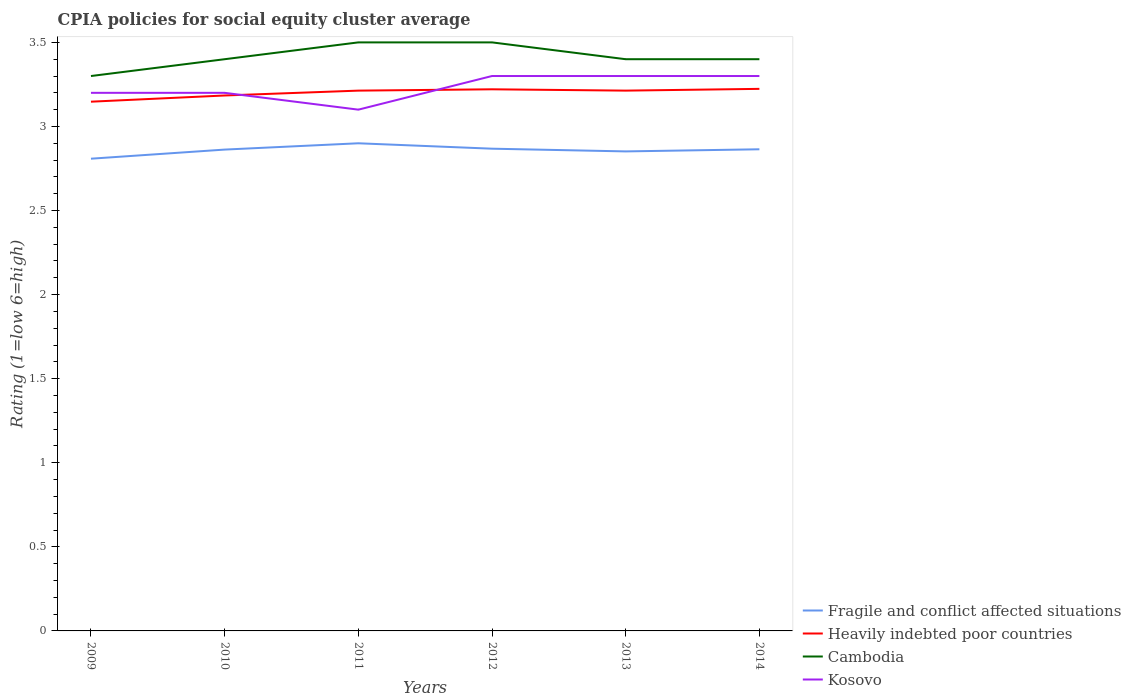Does the line corresponding to Cambodia intersect with the line corresponding to Heavily indebted poor countries?
Offer a terse response. No. Is the number of lines equal to the number of legend labels?
Your response must be concise. Yes. Across all years, what is the maximum CPIA rating in Fragile and conflict affected situations?
Your response must be concise. 2.81. In which year was the CPIA rating in Cambodia maximum?
Your answer should be very brief. 2009. What is the total CPIA rating in Heavily indebted poor countries in the graph?
Offer a very short reply. -0.03. What is the difference between the highest and the second highest CPIA rating in Kosovo?
Ensure brevity in your answer.  0.2. What is the difference between the highest and the lowest CPIA rating in Kosovo?
Offer a terse response. 3. How many lines are there?
Your answer should be compact. 4. How many years are there in the graph?
Give a very brief answer. 6. Are the values on the major ticks of Y-axis written in scientific E-notation?
Your answer should be very brief. No. Does the graph contain any zero values?
Make the answer very short. No. Where does the legend appear in the graph?
Your answer should be compact. Bottom right. What is the title of the graph?
Your response must be concise. CPIA policies for social equity cluster average. Does "Least developed countries" appear as one of the legend labels in the graph?
Make the answer very short. No. What is the label or title of the Y-axis?
Give a very brief answer. Rating (1=low 6=high). What is the Rating (1=low 6=high) in Fragile and conflict affected situations in 2009?
Your response must be concise. 2.81. What is the Rating (1=low 6=high) in Heavily indebted poor countries in 2009?
Your response must be concise. 3.15. What is the Rating (1=low 6=high) of Fragile and conflict affected situations in 2010?
Provide a short and direct response. 2.86. What is the Rating (1=low 6=high) in Heavily indebted poor countries in 2010?
Provide a succinct answer. 3.18. What is the Rating (1=low 6=high) of Fragile and conflict affected situations in 2011?
Your answer should be compact. 2.9. What is the Rating (1=low 6=high) of Heavily indebted poor countries in 2011?
Your answer should be very brief. 3.21. What is the Rating (1=low 6=high) in Kosovo in 2011?
Provide a short and direct response. 3.1. What is the Rating (1=low 6=high) in Fragile and conflict affected situations in 2012?
Provide a short and direct response. 2.87. What is the Rating (1=low 6=high) in Heavily indebted poor countries in 2012?
Your response must be concise. 3.22. What is the Rating (1=low 6=high) in Cambodia in 2012?
Provide a succinct answer. 3.5. What is the Rating (1=low 6=high) in Kosovo in 2012?
Make the answer very short. 3.3. What is the Rating (1=low 6=high) of Fragile and conflict affected situations in 2013?
Give a very brief answer. 2.85. What is the Rating (1=low 6=high) in Heavily indebted poor countries in 2013?
Your answer should be very brief. 3.21. What is the Rating (1=low 6=high) in Cambodia in 2013?
Offer a very short reply. 3.4. What is the Rating (1=low 6=high) of Kosovo in 2013?
Your answer should be compact. 3.3. What is the Rating (1=low 6=high) in Fragile and conflict affected situations in 2014?
Ensure brevity in your answer.  2.86. What is the Rating (1=low 6=high) in Heavily indebted poor countries in 2014?
Your answer should be very brief. 3.22. Across all years, what is the maximum Rating (1=low 6=high) in Heavily indebted poor countries?
Offer a very short reply. 3.22. Across all years, what is the maximum Rating (1=low 6=high) of Cambodia?
Your answer should be compact. 3.5. Across all years, what is the maximum Rating (1=low 6=high) of Kosovo?
Provide a short and direct response. 3.3. Across all years, what is the minimum Rating (1=low 6=high) in Fragile and conflict affected situations?
Provide a short and direct response. 2.81. Across all years, what is the minimum Rating (1=low 6=high) in Heavily indebted poor countries?
Give a very brief answer. 3.15. Across all years, what is the minimum Rating (1=low 6=high) of Kosovo?
Keep it short and to the point. 3.1. What is the total Rating (1=low 6=high) of Fragile and conflict affected situations in the graph?
Ensure brevity in your answer.  17.15. What is the total Rating (1=low 6=high) of Heavily indebted poor countries in the graph?
Ensure brevity in your answer.  19.2. What is the total Rating (1=low 6=high) of Cambodia in the graph?
Your response must be concise. 20.5. What is the total Rating (1=low 6=high) in Kosovo in the graph?
Your answer should be compact. 19.4. What is the difference between the Rating (1=low 6=high) of Fragile and conflict affected situations in 2009 and that in 2010?
Provide a short and direct response. -0.05. What is the difference between the Rating (1=low 6=high) in Heavily indebted poor countries in 2009 and that in 2010?
Offer a terse response. -0.04. What is the difference between the Rating (1=low 6=high) of Cambodia in 2009 and that in 2010?
Keep it short and to the point. -0.1. What is the difference between the Rating (1=low 6=high) in Fragile and conflict affected situations in 2009 and that in 2011?
Provide a short and direct response. -0.09. What is the difference between the Rating (1=low 6=high) of Heavily indebted poor countries in 2009 and that in 2011?
Give a very brief answer. -0.07. What is the difference between the Rating (1=low 6=high) in Cambodia in 2009 and that in 2011?
Make the answer very short. -0.2. What is the difference between the Rating (1=low 6=high) in Kosovo in 2009 and that in 2011?
Make the answer very short. 0.1. What is the difference between the Rating (1=low 6=high) of Fragile and conflict affected situations in 2009 and that in 2012?
Keep it short and to the point. -0.06. What is the difference between the Rating (1=low 6=high) of Heavily indebted poor countries in 2009 and that in 2012?
Keep it short and to the point. -0.07. What is the difference between the Rating (1=low 6=high) in Kosovo in 2009 and that in 2012?
Your response must be concise. -0.1. What is the difference between the Rating (1=low 6=high) of Fragile and conflict affected situations in 2009 and that in 2013?
Keep it short and to the point. -0.04. What is the difference between the Rating (1=low 6=high) in Heavily indebted poor countries in 2009 and that in 2013?
Your answer should be very brief. -0.07. What is the difference between the Rating (1=low 6=high) in Cambodia in 2009 and that in 2013?
Offer a terse response. -0.1. What is the difference between the Rating (1=low 6=high) of Kosovo in 2009 and that in 2013?
Provide a succinct answer. -0.1. What is the difference between the Rating (1=low 6=high) in Fragile and conflict affected situations in 2009 and that in 2014?
Offer a very short reply. -0.06. What is the difference between the Rating (1=low 6=high) in Heavily indebted poor countries in 2009 and that in 2014?
Your answer should be very brief. -0.08. What is the difference between the Rating (1=low 6=high) in Cambodia in 2009 and that in 2014?
Your answer should be compact. -0.1. What is the difference between the Rating (1=low 6=high) of Fragile and conflict affected situations in 2010 and that in 2011?
Your response must be concise. -0.04. What is the difference between the Rating (1=low 6=high) in Heavily indebted poor countries in 2010 and that in 2011?
Your response must be concise. -0.03. What is the difference between the Rating (1=low 6=high) in Cambodia in 2010 and that in 2011?
Provide a short and direct response. -0.1. What is the difference between the Rating (1=low 6=high) in Fragile and conflict affected situations in 2010 and that in 2012?
Give a very brief answer. -0.01. What is the difference between the Rating (1=low 6=high) in Heavily indebted poor countries in 2010 and that in 2012?
Your answer should be compact. -0.04. What is the difference between the Rating (1=low 6=high) of Kosovo in 2010 and that in 2012?
Your answer should be very brief. -0.1. What is the difference between the Rating (1=low 6=high) in Fragile and conflict affected situations in 2010 and that in 2013?
Offer a very short reply. 0.01. What is the difference between the Rating (1=low 6=high) of Heavily indebted poor countries in 2010 and that in 2013?
Offer a terse response. -0.03. What is the difference between the Rating (1=low 6=high) of Cambodia in 2010 and that in 2013?
Your response must be concise. 0. What is the difference between the Rating (1=low 6=high) in Kosovo in 2010 and that in 2013?
Provide a short and direct response. -0.1. What is the difference between the Rating (1=low 6=high) in Fragile and conflict affected situations in 2010 and that in 2014?
Provide a short and direct response. -0. What is the difference between the Rating (1=low 6=high) in Heavily indebted poor countries in 2010 and that in 2014?
Your answer should be compact. -0.04. What is the difference between the Rating (1=low 6=high) in Cambodia in 2010 and that in 2014?
Make the answer very short. 0. What is the difference between the Rating (1=low 6=high) of Kosovo in 2010 and that in 2014?
Provide a succinct answer. -0.1. What is the difference between the Rating (1=low 6=high) in Fragile and conflict affected situations in 2011 and that in 2012?
Your answer should be compact. 0.03. What is the difference between the Rating (1=low 6=high) of Heavily indebted poor countries in 2011 and that in 2012?
Ensure brevity in your answer.  -0.01. What is the difference between the Rating (1=low 6=high) in Cambodia in 2011 and that in 2012?
Make the answer very short. 0. What is the difference between the Rating (1=low 6=high) of Kosovo in 2011 and that in 2012?
Give a very brief answer. -0.2. What is the difference between the Rating (1=low 6=high) in Fragile and conflict affected situations in 2011 and that in 2013?
Give a very brief answer. 0.05. What is the difference between the Rating (1=low 6=high) in Kosovo in 2011 and that in 2013?
Give a very brief answer. -0.2. What is the difference between the Rating (1=low 6=high) of Fragile and conflict affected situations in 2011 and that in 2014?
Keep it short and to the point. 0.04. What is the difference between the Rating (1=low 6=high) in Heavily indebted poor countries in 2011 and that in 2014?
Ensure brevity in your answer.  -0.01. What is the difference between the Rating (1=low 6=high) in Cambodia in 2011 and that in 2014?
Provide a short and direct response. 0.1. What is the difference between the Rating (1=low 6=high) of Kosovo in 2011 and that in 2014?
Give a very brief answer. -0.2. What is the difference between the Rating (1=low 6=high) in Fragile and conflict affected situations in 2012 and that in 2013?
Offer a very short reply. 0.02. What is the difference between the Rating (1=low 6=high) in Heavily indebted poor countries in 2012 and that in 2013?
Offer a very short reply. 0.01. What is the difference between the Rating (1=low 6=high) of Cambodia in 2012 and that in 2013?
Offer a very short reply. 0.1. What is the difference between the Rating (1=low 6=high) of Kosovo in 2012 and that in 2013?
Offer a very short reply. 0. What is the difference between the Rating (1=low 6=high) in Fragile and conflict affected situations in 2012 and that in 2014?
Your answer should be very brief. 0. What is the difference between the Rating (1=low 6=high) in Heavily indebted poor countries in 2012 and that in 2014?
Ensure brevity in your answer.  -0. What is the difference between the Rating (1=low 6=high) of Cambodia in 2012 and that in 2014?
Offer a terse response. 0.1. What is the difference between the Rating (1=low 6=high) of Fragile and conflict affected situations in 2013 and that in 2014?
Offer a terse response. -0.01. What is the difference between the Rating (1=low 6=high) in Heavily indebted poor countries in 2013 and that in 2014?
Your answer should be compact. -0.01. What is the difference between the Rating (1=low 6=high) in Cambodia in 2013 and that in 2014?
Ensure brevity in your answer.  0. What is the difference between the Rating (1=low 6=high) in Fragile and conflict affected situations in 2009 and the Rating (1=low 6=high) in Heavily indebted poor countries in 2010?
Your response must be concise. -0.38. What is the difference between the Rating (1=low 6=high) in Fragile and conflict affected situations in 2009 and the Rating (1=low 6=high) in Cambodia in 2010?
Your response must be concise. -0.59. What is the difference between the Rating (1=low 6=high) of Fragile and conflict affected situations in 2009 and the Rating (1=low 6=high) of Kosovo in 2010?
Your answer should be compact. -0.39. What is the difference between the Rating (1=low 6=high) of Heavily indebted poor countries in 2009 and the Rating (1=low 6=high) of Cambodia in 2010?
Provide a succinct answer. -0.25. What is the difference between the Rating (1=low 6=high) of Heavily indebted poor countries in 2009 and the Rating (1=low 6=high) of Kosovo in 2010?
Provide a short and direct response. -0.05. What is the difference between the Rating (1=low 6=high) in Cambodia in 2009 and the Rating (1=low 6=high) in Kosovo in 2010?
Provide a short and direct response. 0.1. What is the difference between the Rating (1=low 6=high) in Fragile and conflict affected situations in 2009 and the Rating (1=low 6=high) in Heavily indebted poor countries in 2011?
Provide a short and direct response. -0.4. What is the difference between the Rating (1=low 6=high) of Fragile and conflict affected situations in 2009 and the Rating (1=low 6=high) of Cambodia in 2011?
Ensure brevity in your answer.  -0.69. What is the difference between the Rating (1=low 6=high) in Fragile and conflict affected situations in 2009 and the Rating (1=low 6=high) in Kosovo in 2011?
Make the answer very short. -0.29. What is the difference between the Rating (1=low 6=high) in Heavily indebted poor countries in 2009 and the Rating (1=low 6=high) in Cambodia in 2011?
Provide a short and direct response. -0.35. What is the difference between the Rating (1=low 6=high) of Heavily indebted poor countries in 2009 and the Rating (1=low 6=high) of Kosovo in 2011?
Your answer should be very brief. 0.05. What is the difference between the Rating (1=low 6=high) of Fragile and conflict affected situations in 2009 and the Rating (1=low 6=high) of Heavily indebted poor countries in 2012?
Provide a short and direct response. -0.41. What is the difference between the Rating (1=low 6=high) of Fragile and conflict affected situations in 2009 and the Rating (1=low 6=high) of Cambodia in 2012?
Offer a very short reply. -0.69. What is the difference between the Rating (1=low 6=high) of Fragile and conflict affected situations in 2009 and the Rating (1=low 6=high) of Kosovo in 2012?
Provide a short and direct response. -0.49. What is the difference between the Rating (1=low 6=high) of Heavily indebted poor countries in 2009 and the Rating (1=low 6=high) of Cambodia in 2012?
Keep it short and to the point. -0.35. What is the difference between the Rating (1=low 6=high) in Heavily indebted poor countries in 2009 and the Rating (1=low 6=high) in Kosovo in 2012?
Your answer should be compact. -0.15. What is the difference between the Rating (1=low 6=high) of Cambodia in 2009 and the Rating (1=low 6=high) of Kosovo in 2012?
Your response must be concise. 0. What is the difference between the Rating (1=low 6=high) in Fragile and conflict affected situations in 2009 and the Rating (1=low 6=high) in Heavily indebted poor countries in 2013?
Give a very brief answer. -0.4. What is the difference between the Rating (1=low 6=high) of Fragile and conflict affected situations in 2009 and the Rating (1=low 6=high) of Cambodia in 2013?
Your answer should be compact. -0.59. What is the difference between the Rating (1=low 6=high) in Fragile and conflict affected situations in 2009 and the Rating (1=low 6=high) in Kosovo in 2013?
Ensure brevity in your answer.  -0.49. What is the difference between the Rating (1=low 6=high) of Heavily indebted poor countries in 2009 and the Rating (1=low 6=high) of Cambodia in 2013?
Offer a terse response. -0.25. What is the difference between the Rating (1=low 6=high) of Heavily indebted poor countries in 2009 and the Rating (1=low 6=high) of Kosovo in 2013?
Provide a short and direct response. -0.15. What is the difference between the Rating (1=low 6=high) in Cambodia in 2009 and the Rating (1=low 6=high) in Kosovo in 2013?
Offer a very short reply. 0. What is the difference between the Rating (1=low 6=high) in Fragile and conflict affected situations in 2009 and the Rating (1=low 6=high) in Heavily indebted poor countries in 2014?
Your answer should be very brief. -0.42. What is the difference between the Rating (1=low 6=high) in Fragile and conflict affected situations in 2009 and the Rating (1=low 6=high) in Cambodia in 2014?
Give a very brief answer. -0.59. What is the difference between the Rating (1=low 6=high) of Fragile and conflict affected situations in 2009 and the Rating (1=low 6=high) of Kosovo in 2014?
Your answer should be compact. -0.49. What is the difference between the Rating (1=low 6=high) in Heavily indebted poor countries in 2009 and the Rating (1=low 6=high) in Cambodia in 2014?
Your answer should be compact. -0.25. What is the difference between the Rating (1=low 6=high) in Heavily indebted poor countries in 2009 and the Rating (1=low 6=high) in Kosovo in 2014?
Keep it short and to the point. -0.15. What is the difference between the Rating (1=low 6=high) in Cambodia in 2009 and the Rating (1=low 6=high) in Kosovo in 2014?
Ensure brevity in your answer.  0. What is the difference between the Rating (1=low 6=high) in Fragile and conflict affected situations in 2010 and the Rating (1=low 6=high) in Heavily indebted poor countries in 2011?
Ensure brevity in your answer.  -0.35. What is the difference between the Rating (1=low 6=high) of Fragile and conflict affected situations in 2010 and the Rating (1=low 6=high) of Cambodia in 2011?
Offer a terse response. -0.64. What is the difference between the Rating (1=low 6=high) of Fragile and conflict affected situations in 2010 and the Rating (1=low 6=high) of Kosovo in 2011?
Ensure brevity in your answer.  -0.24. What is the difference between the Rating (1=low 6=high) of Heavily indebted poor countries in 2010 and the Rating (1=low 6=high) of Cambodia in 2011?
Give a very brief answer. -0.32. What is the difference between the Rating (1=low 6=high) in Heavily indebted poor countries in 2010 and the Rating (1=low 6=high) in Kosovo in 2011?
Provide a succinct answer. 0.08. What is the difference between the Rating (1=low 6=high) of Fragile and conflict affected situations in 2010 and the Rating (1=low 6=high) of Heavily indebted poor countries in 2012?
Give a very brief answer. -0.36. What is the difference between the Rating (1=low 6=high) of Fragile and conflict affected situations in 2010 and the Rating (1=low 6=high) of Cambodia in 2012?
Ensure brevity in your answer.  -0.64. What is the difference between the Rating (1=low 6=high) of Fragile and conflict affected situations in 2010 and the Rating (1=low 6=high) of Kosovo in 2012?
Give a very brief answer. -0.44. What is the difference between the Rating (1=low 6=high) of Heavily indebted poor countries in 2010 and the Rating (1=low 6=high) of Cambodia in 2012?
Give a very brief answer. -0.32. What is the difference between the Rating (1=low 6=high) of Heavily indebted poor countries in 2010 and the Rating (1=low 6=high) of Kosovo in 2012?
Offer a very short reply. -0.12. What is the difference between the Rating (1=low 6=high) of Fragile and conflict affected situations in 2010 and the Rating (1=low 6=high) of Heavily indebted poor countries in 2013?
Offer a very short reply. -0.35. What is the difference between the Rating (1=low 6=high) in Fragile and conflict affected situations in 2010 and the Rating (1=low 6=high) in Cambodia in 2013?
Ensure brevity in your answer.  -0.54. What is the difference between the Rating (1=low 6=high) of Fragile and conflict affected situations in 2010 and the Rating (1=low 6=high) of Kosovo in 2013?
Make the answer very short. -0.44. What is the difference between the Rating (1=low 6=high) in Heavily indebted poor countries in 2010 and the Rating (1=low 6=high) in Cambodia in 2013?
Offer a terse response. -0.22. What is the difference between the Rating (1=low 6=high) in Heavily indebted poor countries in 2010 and the Rating (1=low 6=high) in Kosovo in 2013?
Your answer should be very brief. -0.12. What is the difference between the Rating (1=low 6=high) of Cambodia in 2010 and the Rating (1=low 6=high) of Kosovo in 2013?
Ensure brevity in your answer.  0.1. What is the difference between the Rating (1=low 6=high) of Fragile and conflict affected situations in 2010 and the Rating (1=low 6=high) of Heavily indebted poor countries in 2014?
Offer a very short reply. -0.36. What is the difference between the Rating (1=low 6=high) in Fragile and conflict affected situations in 2010 and the Rating (1=low 6=high) in Cambodia in 2014?
Your answer should be compact. -0.54. What is the difference between the Rating (1=low 6=high) in Fragile and conflict affected situations in 2010 and the Rating (1=low 6=high) in Kosovo in 2014?
Provide a short and direct response. -0.44. What is the difference between the Rating (1=low 6=high) in Heavily indebted poor countries in 2010 and the Rating (1=low 6=high) in Cambodia in 2014?
Give a very brief answer. -0.22. What is the difference between the Rating (1=low 6=high) in Heavily indebted poor countries in 2010 and the Rating (1=low 6=high) in Kosovo in 2014?
Provide a short and direct response. -0.12. What is the difference between the Rating (1=low 6=high) in Cambodia in 2010 and the Rating (1=low 6=high) in Kosovo in 2014?
Provide a short and direct response. 0.1. What is the difference between the Rating (1=low 6=high) of Fragile and conflict affected situations in 2011 and the Rating (1=low 6=high) of Heavily indebted poor countries in 2012?
Give a very brief answer. -0.32. What is the difference between the Rating (1=low 6=high) of Fragile and conflict affected situations in 2011 and the Rating (1=low 6=high) of Cambodia in 2012?
Provide a succinct answer. -0.6. What is the difference between the Rating (1=low 6=high) in Heavily indebted poor countries in 2011 and the Rating (1=low 6=high) in Cambodia in 2012?
Provide a short and direct response. -0.29. What is the difference between the Rating (1=low 6=high) in Heavily indebted poor countries in 2011 and the Rating (1=low 6=high) in Kosovo in 2012?
Offer a very short reply. -0.09. What is the difference between the Rating (1=low 6=high) of Cambodia in 2011 and the Rating (1=low 6=high) of Kosovo in 2012?
Give a very brief answer. 0.2. What is the difference between the Rating (1=low 6=high) in Fragile and conflict affected situations in 2011 and the Rating (1=low 6=high) in Heavily indebted poor countries in 2013?
Offer a very short reply. -0.31. What is the difference between the Rating (1=low 6=high) of Heavily indebted poor countries in 2011 and the Rating (1=low 6=high) of Cambodia in 2013?
Make the answer very short. -0.19. What is the difference between the Rating (1=low 6=high) in Heavily indebted poor countries in 2011 and the Rating (1=low 6=high) in Kosovo in 2013?
Provide a short and direct response. -0.09. What is the difference between the Rating (1=low 6=high) of Cambodia in 2011 and the Rating (1=low 6=high) of Kosovo in 2013?
Your response must be concise. 0.2. What is the difference between the Rating (1=low 6=high) in Fragile and conflict affected situations in 2011 and the Rating (1=low 6=high) in Heavily indebted poor countries in 2014?
Offer a very short reply. -0.32. What is the difference between the Rating (1=low 6=high) in Heavily indebted poor countries in 2011 and the Rating (1=low 6=high) in Cambodia in 2014?
Give a very brief answer. -0.19. What is the difference between the Rating (1=low 6=high) in Heavily indebted poor countries in 2011 and the Rating (1=low 6=high) in Kosovo in 2014?
Offer a very short reply. -0.09. What is the difference between the Rating (1=low 6=high) of Cambodia in 2011 and the Rating (1=low 6=high) of Kosovo in 2014?
Your answer should be compact. 0.2. What is the difference between the Rating (1=low 6=high) in Fragile and conflict affected situations in 2012 and the Rating (1=low 6=high) in Heavily indebted poor countries in 2013?
Your answer should be very brief. -0.35. What is the difference between the Rating (1=low 6=high) of Fragile and conflict affected situations in 2012 and the Rating (1=low 6=high) of Cambodia in 2013?
Make the answer very short. -0.53. What is the difference between the Rating (1=low 6=high) in Fragile and conflict affected situations in 2012 and the Rating (1=low 6=high) in Kosovo in 2013?
Keep it short and to the point. -0.43. What is the difference between the Rating (1=low 6=high) in Heavily indebted poor countries in 2012 and the Rating (1=low 6=high) in Cambodia in 2013?
Your response must be concise. -0.18. What is the difference between the Rating (1=low 6=high) of Heavily indebted poor countries in 2012 and the Rating (1=low 6=high) of Kosovo in 2013?
Your answer should be very brief. -0.08. What is the difference between the Rating (1=low 6=high) in Cambodia in 2012 and the Rating (1=low 6=high) in Kosovo in 2013?
Your response must be concise. 0.2. What is the difference between the Rating (1=low 6=high) in Fragile and conflict affected situations in 2012 and the Rating (1=low 6=high) in Heavily indebted poor countries in 2014?
Provide a succinct answer. -0.36. What is the difference between the Rating (1=low 6=high) of Fragile and conflict affected situations in 2012 and the Rating (1=low 6=high) of Cambodia in 2014?
Make the answer very short. -0.53. What is the difference between the Rating (1=low 6=high) in Fragile and conflict affected situations in 2012 and the Rating (1=low 6=high) in Kosovo in 2014?
Your response must be concise. -0.43. What is the difference between the Rating (1=low 6=high) of Heavily indebted poor countries in 2012 and the Rating (1=low 6=high) of Cambodia in 2014?
Offer a terse response. -0.18. What is the difference between the Rating (1=low 6=high) of Heavily indebted poor countries in 2012 and the Rating (1=low 6=high) of Kosovo in 2014?
Your answer should be very brief. -0.08. What is the difference between the Rating (1=low 6=high) in Cambodia in 2012 and the Rating (1=low 6=high) in Kosovo in 2014?
Your answer should be very brief. 0.2. What is the difference between the Rating (1=low 6=high) of Fragile and conflict affected situations in 2013 and the Rating (1=low 6=high) of Heavily indebted poor countries in 2014?
Offer a very short reply. -0.37. What is the difference between the Rating (1=low 6=high) in Fragile and conflict affected situations in 2013 and the Rating (1=low 6=high) in Cambodia in 2014?
Keep it short and to the point. -0.55. What is the difference between the Rating (1=low 6=high) in Fragile and conflict affected situations in 2013 and the Rating (1=low 6=high) in Kosovo in 2014?
Provide a short and direct response. -0.45. What is the difference between the Rating (1=low 6=high) in Heavily indebted poor countries in 2013 and the Rating (1=low 6=high) in Cambodia in 2014?
Offer a very short reply. -0.19. What is the difference between the Rating (1=low 6=high) of Heavily indebted poor countries in 2013 and the Rating (1=low 6=high) of Kosovo in 2014?
Ensure brevity in your answer.  -0.09. What is the average Rating (1=low 6=high) in Fragile and conflict affected situations per year?
Your response must be concise. 2.86. What is the average Rating (1=low 6=high) in Heavily indebted poor countries per year?
Offer a very short reply. 3.2. What is the average Rating (1=low 6=high) in Cambodia per year?
Your answer should be very brief. 3.42. What is the average Rating (1=low 6=high) of Kosovo per year?
Keep it short and to the point. 3.23. In the year 2009, what is the difference between the Rating (1=low 6=high) of Fragile and conflict affected situations and Rating (1=low 6=high) of Heavily indebted poor countries?
Your response must be concise. -0.34. In the year 2009, what is the difference between the Rating (1=low 6=high) of Fragile and conflict affected situations and Rating (1=low 6=high) of Cambodia?
Offer a very short reply. -0.49. In the year 2009, what is the difference between the Rating (1=low 6=high) in Fragile and conflict affected situations and Rating (1=low 6=high) in Kosovo?
Keep it short and to the point. -0.39. In the year 2009, what is the difference between the Rating (1=low 6=high) of Heavily indebted poor countries and Rating (1=low 6=high) of Cambodia?
Provide a succinct answer. -0.15. In the year 2009, what is the difference between the Rating (1=low 6=high) in Heavily indebted poor countries and Rating (1=low 6=high) in Kosovo?
Your response must be concise. -0.05. In the year 2009, what is the difference between the Rating (1=low 6=high) in Cambodia and Rating (1=low 6=high) in Kosovo?
Offer a terse response. 0.1. In the year 2010, what is the difference between the Rating (1=low 6=high) in Fragile and conflict affected situations and Rating (1=low 6=high) in Heavily indebted poor countries?
Your response must be concise. -0.32. In the year 2010, what is the difference between the Rating (1=low 6=high) of Fragile and conflict affected situations and Rating (1=low 6=high) of Cambodia?
Your response must be concise. -0.54. In the year 2010, what is the difference between the Rating (1=low 6=high) of Fragile and conflict affected situations and Rating (1=low 6=high) of Kosovo?
Keep it short and to the point. -0.34. In the year 2010, what is the difference between the Rating (1=low 6=high) of Heavily indebted poor countries and Rating (1=low 6=high) of Cambodia?
Your answer should be compact. -0.22. In the year 2010, what is the difference between the Rating (1=low 6=high) of Heavily indebted poor countries and Rating (1=low 6=high) of Kosovo?
Your answer should be very brief. -0.02. In the year 2011, what is the difference between the Rating (1=low 6=high) of Fragile and conflict affected situations and Rating (1=low 6=high) of Heavily indebted poor countries?
Your response must be concise. -0.31. In the year 2011, what is the difference between the Rating (1=low 6=high) of Fragile and conflict affected situations and Rating (1=low 6=high) of Kosovo?
Your answer should be compact. -0.2. In the year 2011, what is the difference between the Rating (1=low 6=high) of Heavily indebted poor countries and Rating (1=low 6=high) of Cambodia?
Provide a short and direct response. -0.29. In the year 2011, what is the difference between the Rating (1=low 6=high) in Heavily indebted poor countries and Rating (1=low 6=high) in Kosovo?
Make the answer very short. 0.11. In the year 2011, what is the difference between the Rating (1=low 6=high) of Cambodia and Rating (1=low 6=high) of Kosovo?
Keep it short and to the point. 0.4. In the year 2012, what is the difference between the Rating (1=low 6=high) of Fragile and conflict affected situations and Rating (1=low 6=high) of Heavily indebted poor countries?
Offer a terse response. -0.35. In the year 2012, what is the difference between the Rating (1=low 6=high) of Fragile and conflict affected situations and Rating (1=low 6=high) of Cambodia?
Your answer should be compact. -0.63. In the year 2012, what is the difference between the Rating (1=low 6=high) in Fragile and conflict affected situations and Rating (1=low 6=high) in Kosovo?
Ensure brevity in your answer.  -0.43. In the year 2012, what is the difference between the Rating (1=low 6=high) of Heavily indebted poor countries and Rating (1=low 6=high) of Cambodia?
Offer a terse response. -0.28. In the year 2012, what is the difference between the Rating (1=low 6=high) of Heavily indebted poor countries and Rating (1=low 6=high) of Kosovo?
Offer a very short reply. -0.08. In the year 2013, what is the difference between the Rating (1=low 6=high) in Fragile and conflict affected situations and Rating (1=low 6=high) in Heavily indebted poor countries?
Provide a short and direct response. -0.36. In the year 2013, what is the difference between the Rating (1=low 6=high) of Fragile and conflict affected situations and Rating (1=low 6=high) of Cambodia?
Offer a terse response. -0.55. In the year 2013, what is the difference between the Rating (1=low 6=high) in Fragile and conflict affected situations and Rating (1=low 6=high) in Kosovo?
Keep it short and to the point. -0.45. In the year 2013, what is the difference between the Rating (1=low 6=high) in Heavily indebted poor countries and Rating (1=low 6=high) in Cambodia?
Offer a terse response. -0.19. In the year 2013, what is the difference between the Rating (1=low 6=high) in Heavily indebted poor countries and Rating (1=low 6=high) in Kosovo?
Offer a very short reply. -0.09. In the year 2013, what is the difference between the Rating (1=low 6=high) in Cambodia and Rating (1=low 6=high) in Kosovo?
Keep it short and to the point. 0.1. In the year 2014, what is the difference between the Rating (1=low 6=high) in Fragile and conflict affected situations and Rating (1=low 6=high) in Heavily indebted poor countries?
Provide a succinct answer. -0.36. In the year 2014, what is the difference between the Rating (1=low 6=high) in Fragile and conflict affected situations and Rating (1=low 6=high) in Cambodia?
Provide a short and direct response. -0.54. In the year 2014, what is the difference between the Rating (1=low 6=high) in Fragile and conflict affected situations and Rating (1=low 6=high) in Kosovo?
Ensure brevity in your answer.  -0.44. In the year 2014, what is the difference between the Rating (1=low 6=high) in Heavily indebted poor countries and Rating (1=low 6=high) in Cambodia?
Your answer should be compact. -0.18. In the year 2014, what is the difference between the Rating (1=low 6=high) of Heavily indebted poor countries and Rating (1=low 6=high) of Kosovo?
Ensure brevity in your answer.  -0.08. In the year 2014, what is the difference between the Rating (1=low 6=high) of Cambodia and Rating (1=low 6=high) of Kosovo?
Make the answer very short. 0.1. What is the ratio of the Rating (1=low 6=high) of Fragile and conflict affected situations in 2009 to that in 2010?
Keep it short and to the point. 0.98. What is the ratio of the Rating (1=low 6=high) of Heavily indebted poor countries in 2009 to that in 2010?
Make the answer very short. 0.99. What is the ratio of the Rating (1=low 6=high) of Cambodia in 2009 to that in 2010?
Your response must be concise. 0.97. What is the ratio of the Rating (1=low 6=high) of Fragile and conflict affected situations in 2009 to that in 2011?
Your response must be concise. 0.97. What is the ratio of the Rating (1=low 6=high) of Heavily indebted poor countries in 2009 to that in 2011?
Provide a short and direct response. 0.98. What is the ratio of the Rating (1=low 6=high) in Cambodia in 2009 to that in 2011?
Give a very brief answer. 0.94. What is the ratio of the Rating (1=low 6=high) in Kosovo in 2009 to that in 2011?
Offer a terse response. 1.03. What is the ratio of the Rating (1=low 6=high) of Fragile and conflict affected situations in 2009 to that in 2012?
Provide a succinct answer. 0.98. What is the ratio of the Rating (1=low 6=high) in Heavily indebted poor countries in 2009 to that in 2012?
Provide a short and direct response. 0.98. What is the ratio of the Rating (1=low 6=high) of Cambodia in 2009 to that in 2012?
Ensure brevity in your answer.  0.94. What is the ratio of the Rating (1=low 6=high) in Kosovo in 2009 to that in 2012?
Keep it short and to the point. 0.97. What is the ratio of the Rating (1=low 6=high) of Heavily indebted poor countries in 2009 to that in 2013?
Ensure brevity in your answer.  0.98. What is the ratio of the Rating (1=low 6=high) of Cambodia in 2009 to that in 2013?
Your answer should be very brief. 0.97. What is the ratio of the Rating (1=low 6=high) of Kosovo in 2009 to that in 2013?
Your answer should be compact. 0.97. What is the ratio of the Rating (1=low 6=high) in Fragile and conflict affected situations in 2009 to that in 2014?
Keep it short and to the point. 0.98. What is the ratio of the Rating (1=low 6=high) of Heavily indebted poor countries in 2009 to that in 2014?
Your answer should be very brief. 0.98. What is the ratio of the Rating (1=low 6=high) of Cambodia in 2009 to that in 2014?
Offer a terse response. 0.97. What is the ratio of the Rating (1=low 6=high) of Kosovo in 2009 to that in 2014?
Offer a very short reply. 0.97. What is the ratio of the Rating (1=low 6=high) in Fragile and conflict affected situations in 2010 to that in 2011?
Provide a succinct answer. 0.99. What is the ratio of the Rating (1=low 6=high) in Cambodia in 2010 to that in 2011?
Keep it short and to the point. 0.97. What is the ratio of the Rating (1=low 6=high) of Kosovo in 2010 to that in 2011?
Your answer should be very brief. 1.03. What is the ratio of the Rating (1=low 6=high) of Fragile and conflict affected situations in 2010 to that in 2012?
Offer a very short reply. 1. What is the ratio of the Rating (1=low 6=high) in Heavily indebted poor countries in 2010 to that in 2012?
Your response must be concise. 0.99. What is the ratio of the Rating (1=low 6=high) in Cambodia in 2010 to that in 2012?
Ensure brevity in your answer.  0.97. What is the ratio of the Rating (1=low 6=high) of Kosovo in 2010 to that in 2012?
Offer a terse response. 0.97. What is the ratio of the Rating (1=low 6=high) in Kosovo in 2010 to that in 2013?
Provide a succinct answer. 0.97. What is the ratio of the Rating (1=low 6=high) in Fragile and conflict affected situations in 2010 to that in 2014?
Keep it short and to the point. 1. What is the ratio of the Rating (1=low 6=high) in Kosovo in 2010 to that in 2014?
Make the answer very short. 0.97. What is the ratio of the Rating (1=low 6=high) in Fragile and conflict affected situations in 2011 to that in 2012?
Your response must be concise. 1.01. What is the ratio of the Rating (1=low 6=high) of Heavily indebted poor countries in 2011 to that in 2012?
Your answer should be compact. 1. What is the ratio of the Rating (1=low 6=high) in Kosovo in 2011 to that in 2012?
Keep it short and to the point. 0.94. What is the ratio of the Rating (1=low 6=high) of Fragile and conflict affected situations in 2011 to that in 2013?
Offer a terse response. 1.02. What is the ratio of the Rating (1=low 6=high) in Heavily indebted poor countries in 2011 to that in 2013?
Make the answer very short. 1. What is the ratio of the Rating (1=low 6=high) in Cambodia in 2011 to that in 2013?
Provide a succinct answer. 1.03. What is the ratio of the Rating (1=low 6=high) of Kosovo in 2011 to that in 2013?
Make the answer very short. 0.94. What is the ratio of the Rating (1=low 6=high) of Fragile and conflict affected situations in 2011 to that in 2014?
Give a very brief answer. 1.01. What is the ratio of the Rating (1=low 6=high) of Cambodia in 2011 to that in 2014?
Your answer should be compact. 1.03. What is the ratio of the Rating (1=low 6=high) of Kosovo in 2011 to that in 2014?
Keep it short and to the point. 0.94. What is the ratio of the Rating (1=low 6=high) of Heavily indebted poor countries in 2012 to that in 2013?
Provide a succinct answer. 1. What is the ratio of the Rating (1=low 6=high) in Cambodia in 2012 to that in 2013?
Your response must be concise. 1.03. What is the ratio of the Rating (1=low 6=high) of Kosovo in 2012 to that in 2013?
Ensure brevity in your answer.  1. What is the ratio of the Rating (1=low 6=high) in Fragile and conflict affected situations in 2012 to that in 2014?
Offer a very short reply. 1. What is the ratio of the Rating (1=low 6=high) of Heavily indebted poor countries in 2012 to that in 2014?
Make the answer very short. 1. What is the ratio of the Rating (1=low 6=high) in Cambodia in 2012 to that in 2014?
Provide a succinct answer. 1.03. What is the ratio of the Rating (1=low 6=high) of Kosovo in 2012 to that in 2014?
Your answer should be compact. 1. What is the ratio of the Rating (1=low 6=high) of Fragile and conflict affected situations in 2013 to that in 2014?
Keep it short and to the point. 1. What is the ratio of the Rating (1=low 6=high) in Heavily indebted poor countries in 2013 to that in 2014?
Keep it short and to the point. 1. What is the ratio of the Rating (1=low 6=high) in Cambodia in 2013 to that in 2014?
Your response must be concise. 1. What is the difference between the highest and the second highest Rating (1=low 6=high) of Fragile and conflict affected situations?
Provide a succinct answer. 0.03. What is the difference between the highest and the second highest Rating (1=low 6=high) of Heavily indebted poor countries?
Provide a succinct answer. 0. What is the difference between the highest and the second highest Rating (1=low 6=high) of Cambodia?
Give a very brief answer. 0. What is the difference between the highest and the lowest Rating (1=low 6=high) of Fragile and conflict affected situations?
Your answer should be compact. 0.09. What is the difference between the highest and the lowest Rating (1=low 6=high) in Heavily indebted poor countries?
Keep it short and to the point. 0.08. 